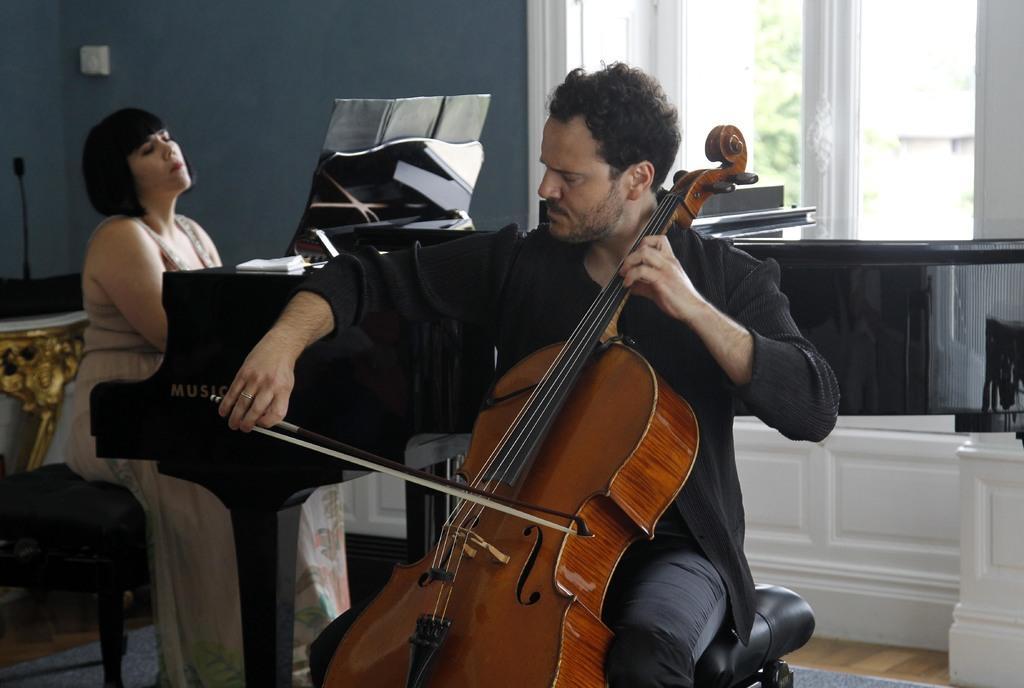Could you give a brief overview of what you see in this image? In this picture we can see a man playing a violin, here we can see a woman, harmonium, files, socket board and some objects. In the background we can see a wall, windows, from windows we can see trees. 